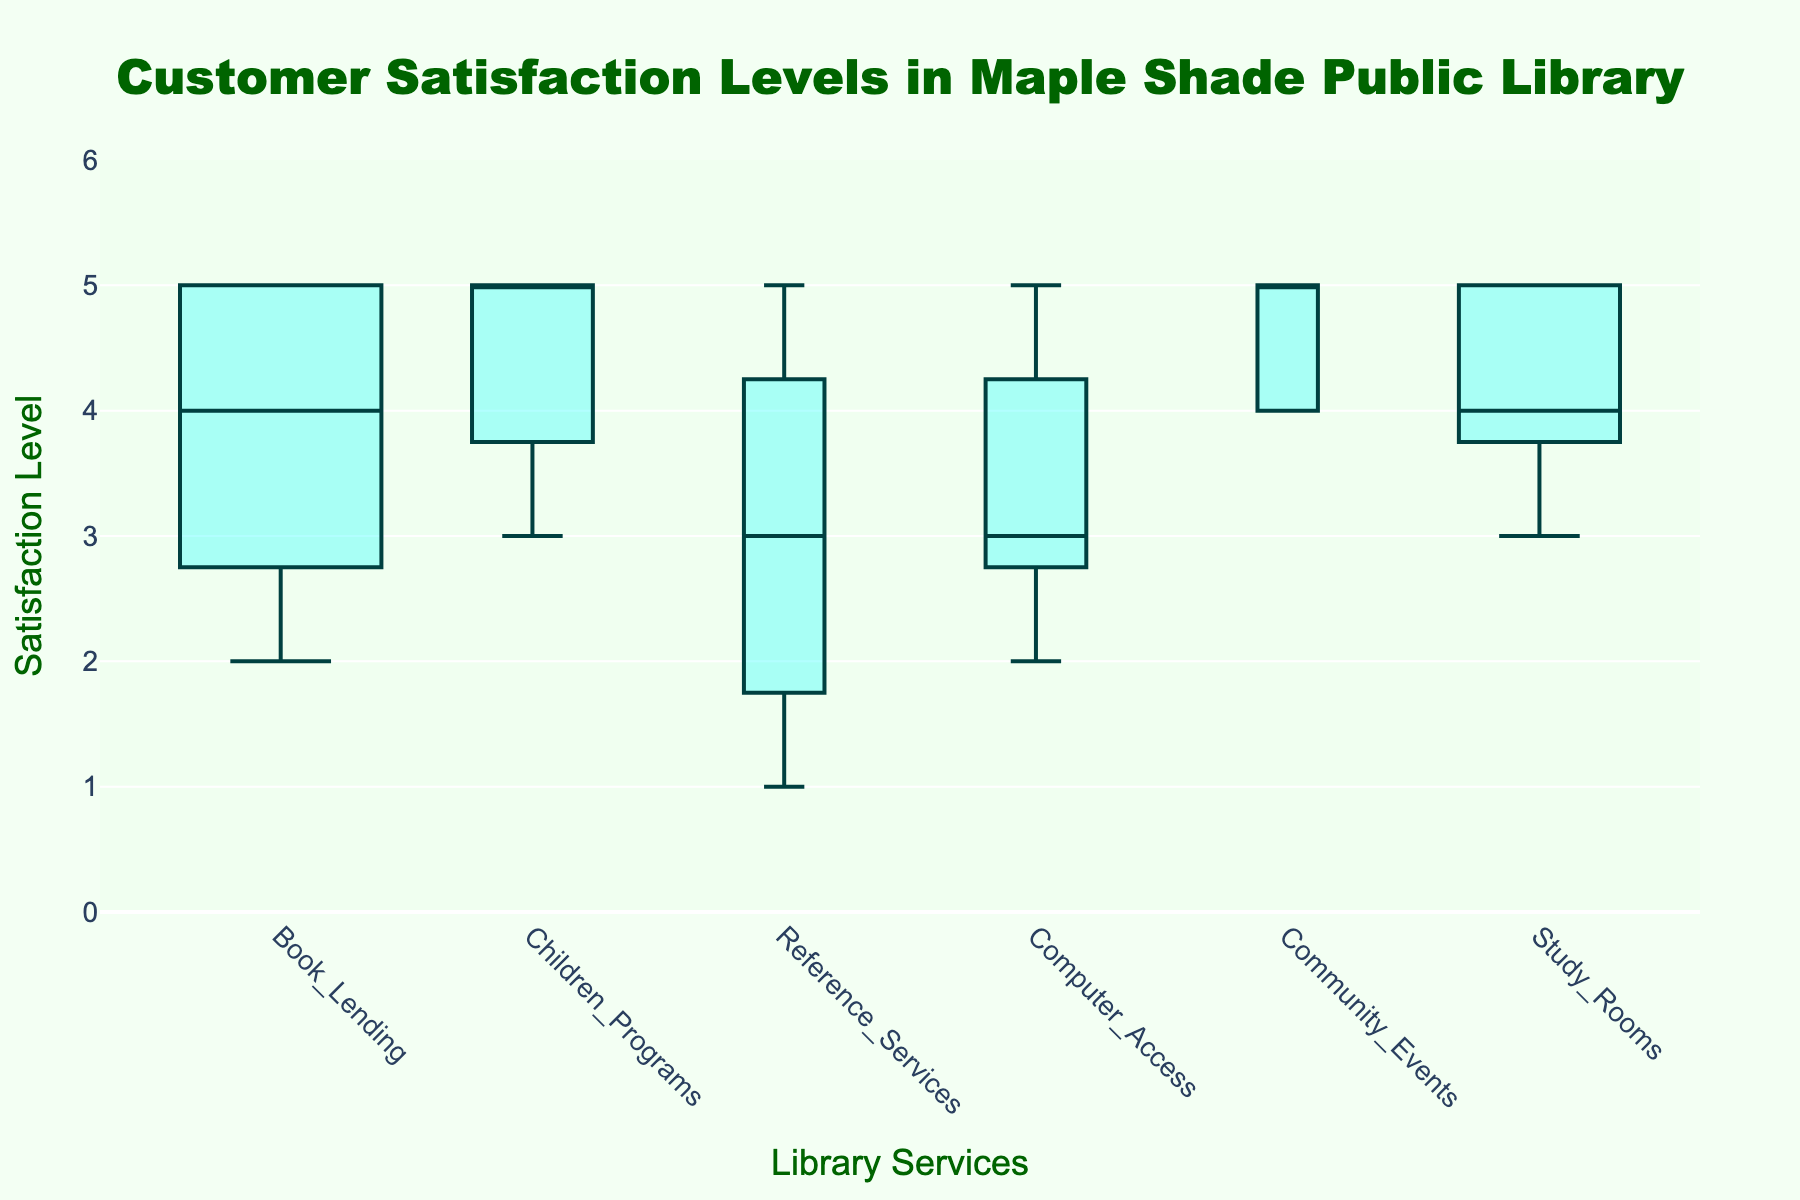What's the title of the figure? The title is prominently displayed at the top of the figure in a large, dark green font.
Answer: Customer Satisfaction Levels in Maple Shade Public Library What is the satisfaction level range used in the y-axis? The y-axis represents the satisfaction levels with a vertical range from 0 to 6, as evident from the axis titles and ticks.
Answer: 0 to 6 Which service has the widest box plot? To determine the widest box plot, look at the width of each box in the figure. The width is proportional to the number of respondents.
Answer: Book Lending Which two services have median satisfaction levels of 5? Find the median lines for each box plot and identify which ones align with the value of 5 on the y-axis. Look for lines that bisect the boxes horizontally at the 5 mark.
Answer: Children Programs and Community Events What is the minimum satisfaction level recorded for Reference Services? The minimum satisfaction level is represented by the lower whisker of the box plot for Reference Services. Observe the lowest point of the whisker for the Reference Services box.
Answer: 1 How does the median satisfaction level of Study Rooms compare to that of Computer Access? Identify the median lines in both Study Rooms and Computer Access box plots and compare their values.
Answer: Study Rooms has a higher median than Computer Access Which service has the highest minimum satisfaction level? Observe the lower whisker of each box plot. The service with the highest lower whisker has the highest minimum satisfaction level.
Answer: Community Events Does Book Lending or Study Rooms have a higher 1st quartile satisfaction level? Compare the position of the 1st quartile lines (bottom of the box) for both Book Lending and Study Rooms to see which is higher.
Answer: Study Rooms What is the interquartile range (IQR) for Computer Access? The IQR is the difference between the 3rd and 1st quartile values. For Computer Access, find these values on the box and subtract the 1st quartile from the 3rd quartile.
Answer: 1 Which service shows the most variability in satisfaction levels? The variability is reflected in the range between the minimum and maximum values. Identify which box plot has the widest range between its whiskers.
Answer: Reference Services 